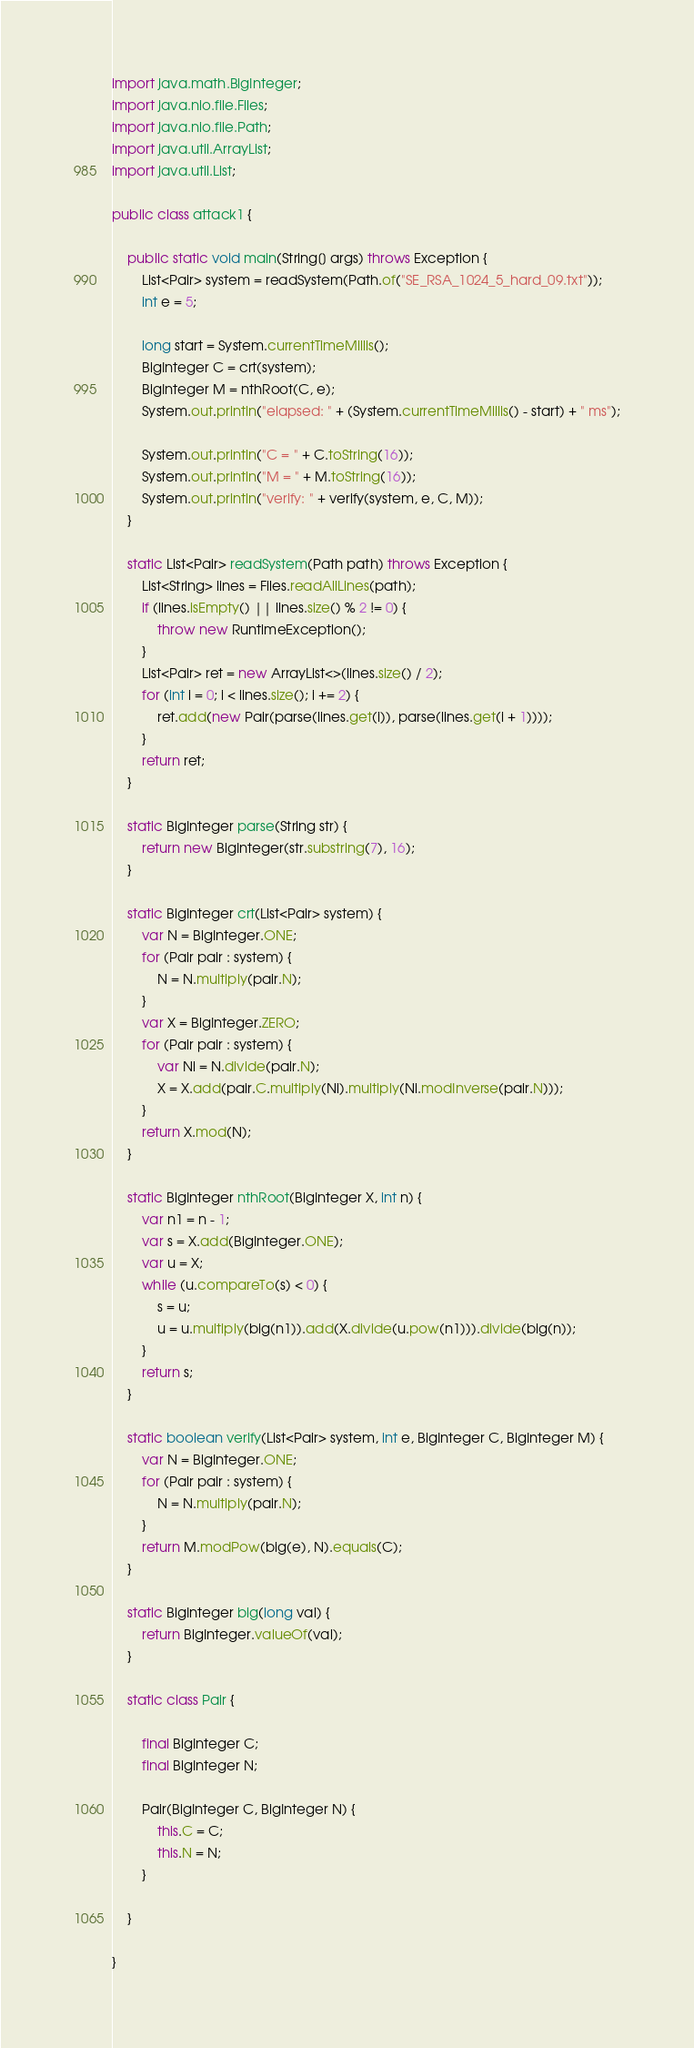<code> <loc_0><loc_0><loc_500><loc_500><_Java_>import java.math.BigInteger;
import java.nio.file.Files;
import java.nio.file.Path;
import java.util.ArrayList;
import java.util.List;

public class attack1 {

    public static void main(String[] args) throws Exception {
        List<Pair> system = readSystem(Path.of("SE_RSA_1024_5_hard_09.txt"));
        int e = 5;

        long start = System.currentTimeMillis();
        BigInteger C = crt(system);
        BigInteger M = nthRoot(C, e);
        System.out.println("elapsed: " + (System.currentTimeMillis() - start) + " ms");

        System.out.println("C = " + C.toString(16));
        System.out.println("M = " + M.toString(16));
        System.out.println("verify: " + verify(system, e, C, M));
    }

    static List<Pair> readSystem(Path path) throws Exception {
        List<String> lines = Files.readAllLines(path);
        if (lines.isEmpty() || lines.size() % 2 != 0) {
            throw new RuntimeException();
        }
        List<Pair> ret = new ArrayList<>(lines.size() / 2);
        for (int i = 0; i < lines.size(); i += 2) {
            ret.add(new Pair(parse(lines.get(i)), parse(lines.get(i + 1))));
        }
        return ret;
    }

    static BigInteger parse(String str) {
        return new BigInteger(str.substring(7), 16);
    }

    static BigInteger crt(List<Pair> system) {
        var N = BigInteger.ONE;
        for (Pair pair : system) {
            N = N.multiply(pair.N);
        }
        var X = BigInteger.ZERO;
        for (Pair pair : system) {
            var Ni = N.divide(pair.N);
            X = X.add(pair.C.multiply(Ni).multiply(Ni.modInverse(pair.N)));
        }
        return X.mod(N);
    }

    static BigInteger nthRoot(BigInteger X, int n) {
        var n1 = n - 1;
        var s = X.add(BigInteger.ONE);
        var u = X;
        while (u.compareTo(s) < 0) {
            s = u;
            u = u.multiply(big(n1)).add(X.divide(u.pow(n1))).divide(big(n));
        }
        return s;
    }

    static boolean verify(List<Pair> system, int e, BigInteger C, BigInteger M) {
        var N = BigInteger.ONE;
        for (Pair pair : system) {
            N = N.multiply(pair.N);
        }
        return M.modPow(big(e), N).equals(C);
    }

    static BigInteger big(long val) {
        return BigInteger.valueOf(val);
    }

    static class Pair {

        final BigInteger C;
        final BigInteger N;

        Pair(BigInteger C, BigInteger N) {
            this.C = C;
            this.N = N;
        }

    }

}
</code> 